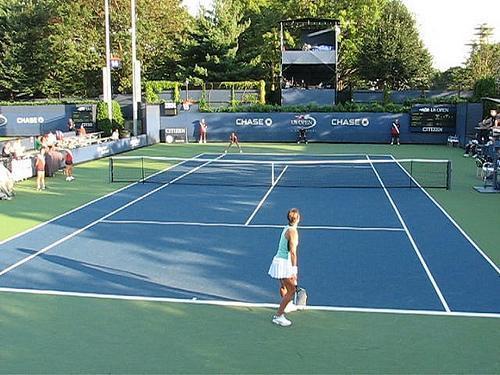How many chase logo signs are in this image?
Give a very brief answer. 3. 